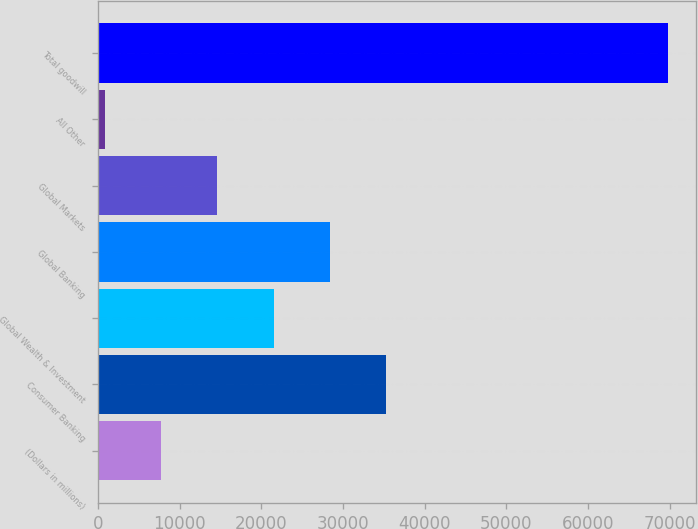<chart> <loc_0><loc_0><loc_500><loc_500><bar_chart><fcel>(Dollars in millions)<fcel>Consumer Banking<fcel>Global Wealth & Investment<fcel>Global Banking<fcel>Global Markets<fcel>All Other<fcel>Total goodwill<nl><fcel>7714.1<fcel>35290.5<fcel>21502.3<fcel>28396.4<fcel>14608.2<fcel>820<fcel>69761<nl></chart> 